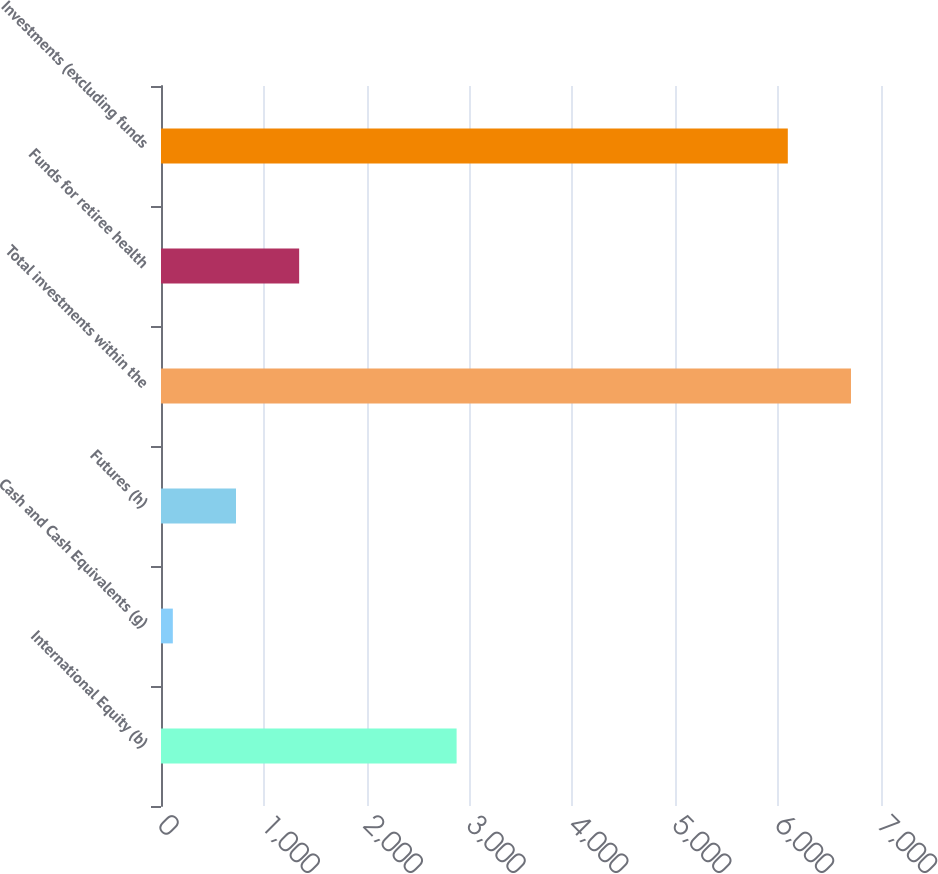Convert chart. <chart><loc_0><loc_0><loc_500><loc_500><bar_chart><fcel>International Equity (b)<fcel>Cash and Cash Equivalents (g)<fcel>Futures (h)<fcel>Total investments within the<fcel>Funds for retiree health<fcel>Investments (excluding funds<nl><fcel>2874<fcel>115<fcel>729.1<fcel>6708.1<fcel>1343.2<fcel>6094<nl></chart> 